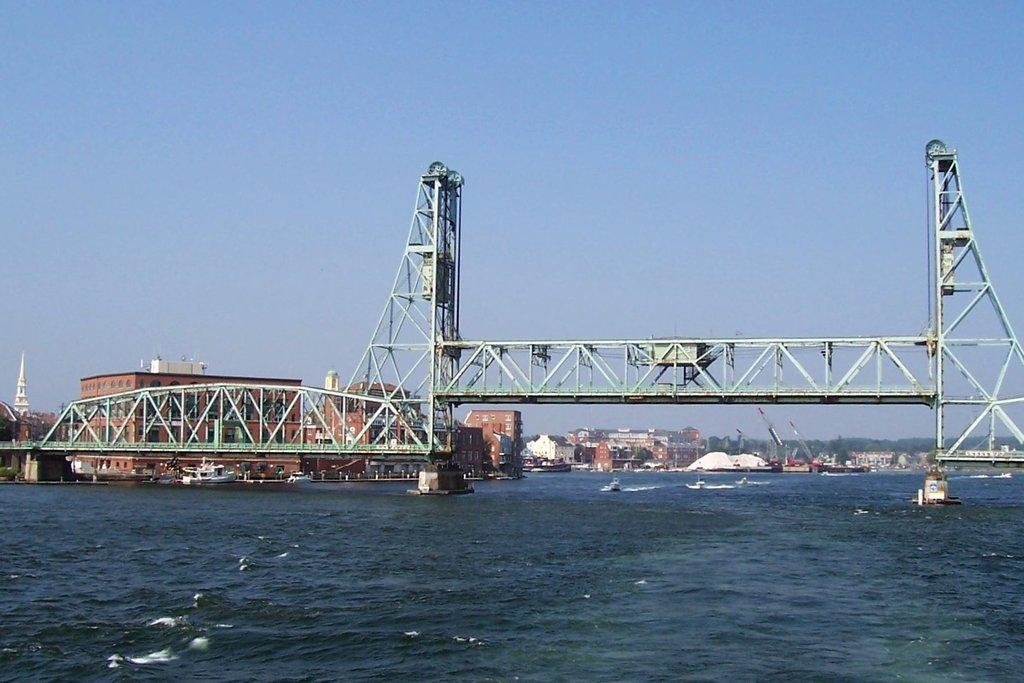What is in the foreground of the image? There is water in the foreground of the image. What structure can be seen in the middle of the image? There is a bridge in the middle of the image. What can be seen in the background of the image? There are buildings, boats, greenery, and the sky visible in the background. What type of produce is being harvested on the bridge in the image? There is no produce or harvesting activity depicted on the bridge in the image. How many chances does the person in the image have to cough before they are asked to leave? There is no person in the image, and therefore no one to cough or be asked to leave. 